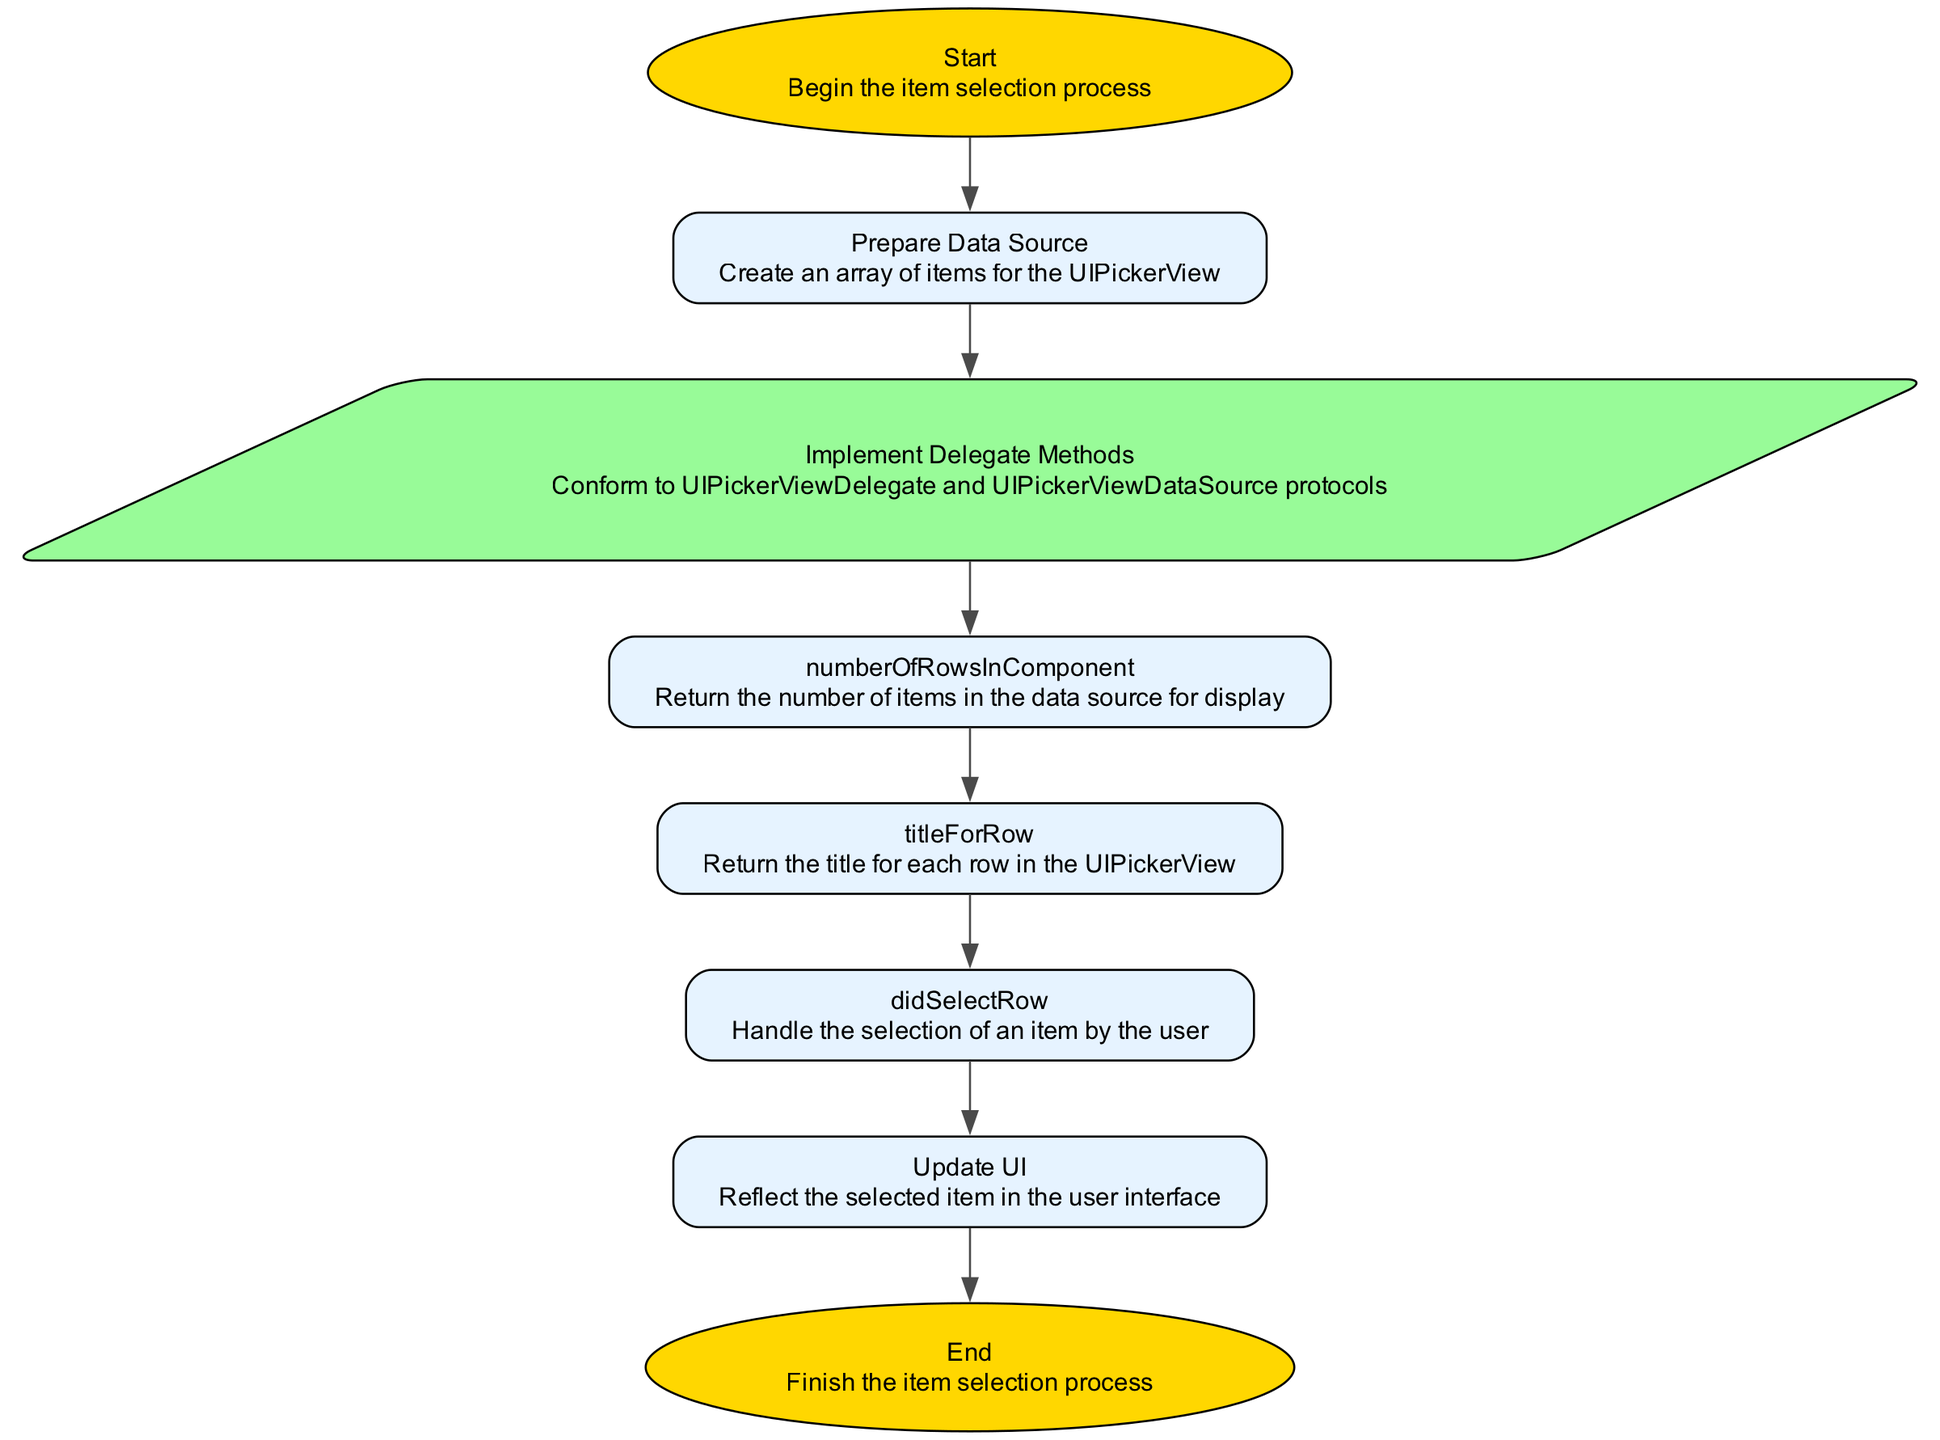What is the first step in the workflow? The diagram indicates that the first step in the workflow is labeled "Start." This is represented as the initial node in the flowchart and leads to the next step.
Answer: Start How many delegate methods are implemented in the workflow? Based on the diagram, there are three delegate methods identified: "numberOfRowsInComponent," "titleForRow," and "didSelectRow." Counting these gives a total of three.
Answer: 3 What is the last step of the workflow? The diagram specifies that the last step in the workflow is labeled "End." This is the terminal node after all processing is complete and signifies the conclusion of the item selection process.
Answer: End What does the "didSelectRow" step represent? The "didSelectRow" step represents the action where the app handles a user selecting an item from the UIPickerView. It's a crucial part of user interaction in the workflow.
Answer: Handle the selection of an item What do the shapes of the nodes represent? The diagram uses different shapes for nodes: elliptical shapes for "Start" and "End" indicate process beginnings and endings, while rectangular shapes are used for the rest, showing standard process steps.
Answer: Different shapes represent types of nodes What is the relationship between "Update UI" and "didSelectRow"? The "Update UI" node follows the "didSelectRow" node in the flow, indicating that once an item is selected, the user interface is subsequently updated to reflect this selection. This shows a direct sequential dependency in the workflow.
Answer: "Update UI" follows "didSelectRow" Which step prepares the data for the UIPickerView? The "Prepare Data Source" step is specifically responsible for creating an array of items that will be utilized by the UIPickerView. This is the initial data preparation stage before displaying any items.
Answer: Prepare Data Source How many edges are there in the workflow? The flowchart connects all steps with edges leading from one node to another. By counting the edges represented in the diagram, we find that there are seven edges connecting the eight nodes sequentially.
Answer: 7 